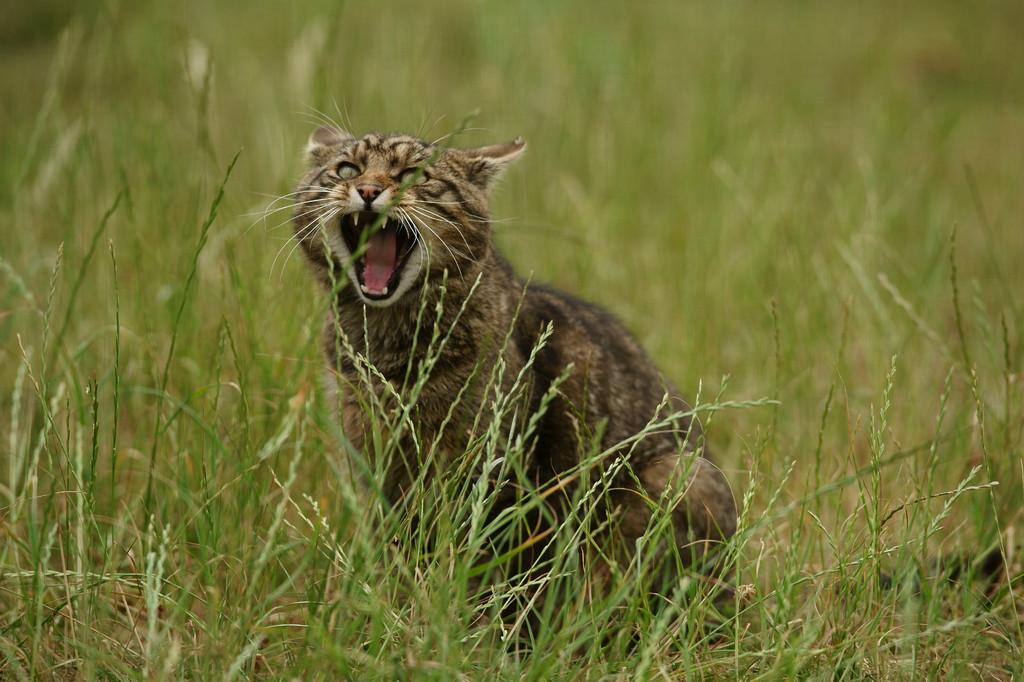What type of animal is in the image? There is a wild cat in the image. Where is the wild cat located? The wild cat is sitting in the grass plants. What type of sport is being played in the image? There is no sport being played in the image; it features a wild cat sitting in the grass plants. What type of government official can be seen in the image? There is no government official, such as a minister, present in the image. 